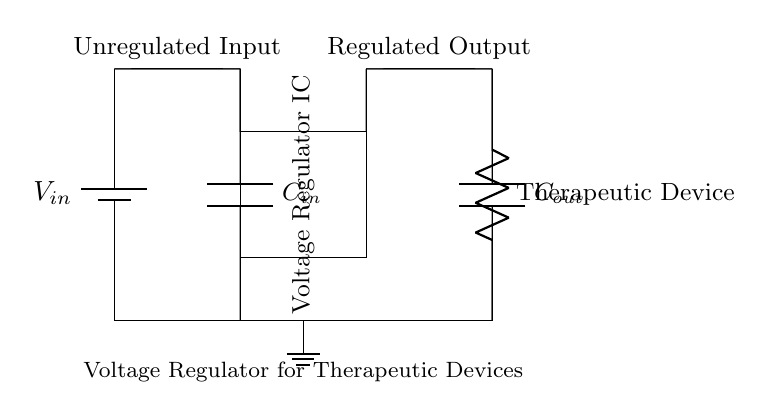What is the main component that maintains a consistent voltage? The main component is the Voltage Regulator IC, which provides regulation of the output voltage despite variations in input voltage or load conditions.
Answer: Voltage Regulator IC What type of device is connected at the output of the circuit? The output is connected to a therapeutic device, indicating that this circuit is designed to provide stable power for such applications.
Answer: Therapeutic Device What is the purpose of the capacitors in the circuit? The capacitors (input and output) help stabilize the voltage by smoothing out any fluctuations, ensuring a consistent power supply to the therapeutic device.
Answer: Stabilization Which capacitor is connected to the input of the voltage regulator? The capacitor connected at the input is denoted as Cin, and it is crucial for filtering the input voltage.
Answer: C in How many capacitors are present in the circuit? There are two capacitors in the circuit, one at the input (C in) and one at the output (C out), each serving its function in voltage regulation.
Answer: Two What is the configuration of the ground connection in the circuit? The ground connection is at the bottom of the diagram, indicating the reference point for the circuit and connecting all components to the ground.
Answer: Bottom What does the unregulated input signify in this circuit? The unregulated input signifies the voltage supplied to the circuit before it enters the regulator, which will then convert it into a regulated output.
Answer: Unregulated Input 